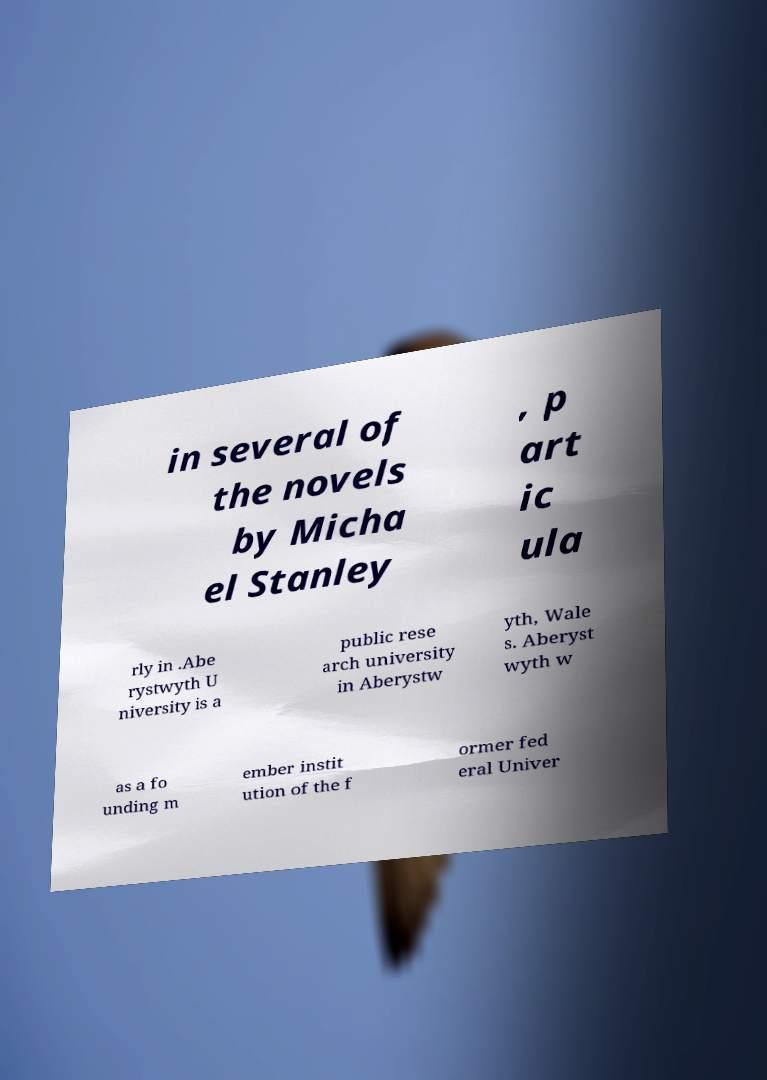Could you extract and type out the text from this image? in several of the novels by Micha el Stanley , p art ic ula rly in .Abe rystwyth U niversity is a public rese arch university in Aberystw yth, Wale s. Aberyst wyth w as a fo unding m ember instit ution of the f ormer fed eral Univer 